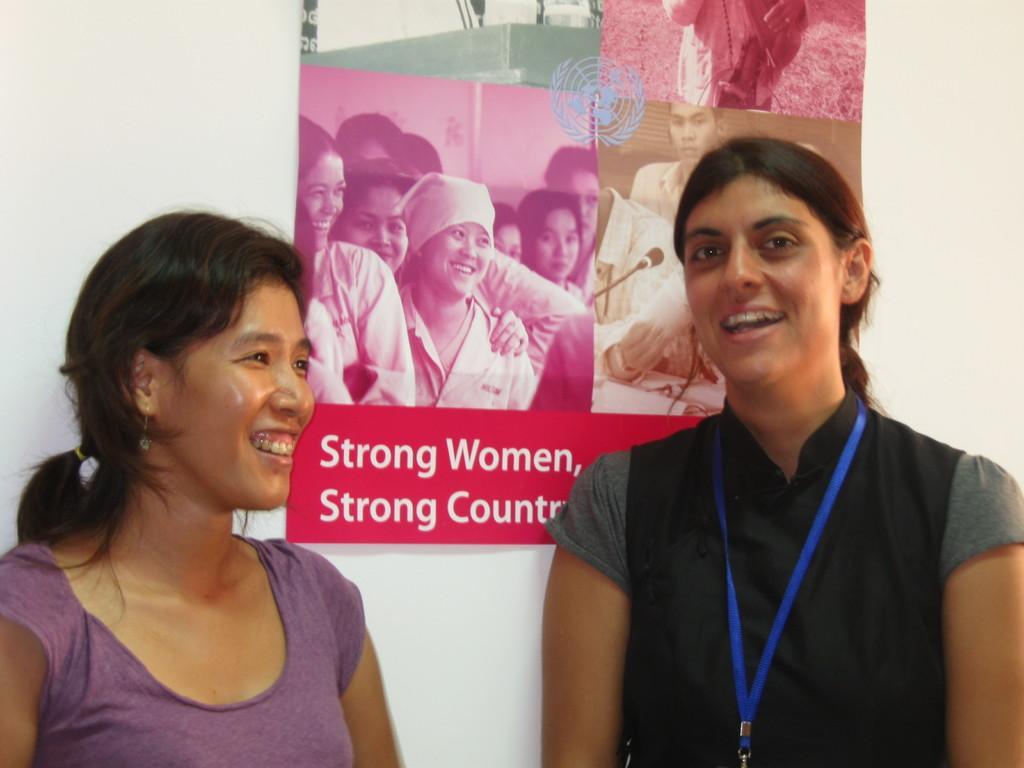Can you describe this image briefly? In this image we can see a few people, behind them there is a poster with text and images of persons on it, which is on the wall. 